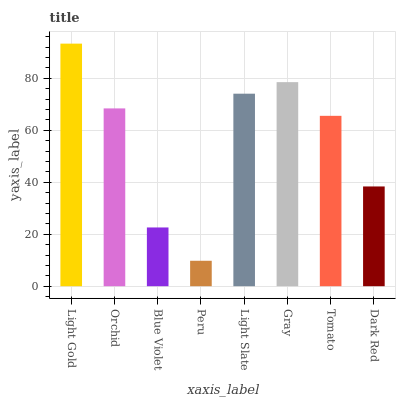Is Peru the minimum?
Answer yes or no. Yes. Is Light Gold the maximum?
Answer yes or no. Yes. Is Orchid the minimum?
Answer yes or no. No. Is Orchid the maximum?
Answer yes or no. No. Is Light Gold greater than Orchid?
Answer yes or no. Yes. Is Orchid less than Light Gold?
Answer yes or no. Yes. Is Orchid greater than Light Gold?
Answer yes or no. No. Is Light Gold less than Orchid?
Answer yes or no. No. Is Orchid the high median?
Answer yes or no. Yes. Is Tomato the low median?
Answer yes or no. Yes. Is Tomato the high median?
Answer yes or no. No. Is Light Gold the low median?
Answer yes or no. No. 